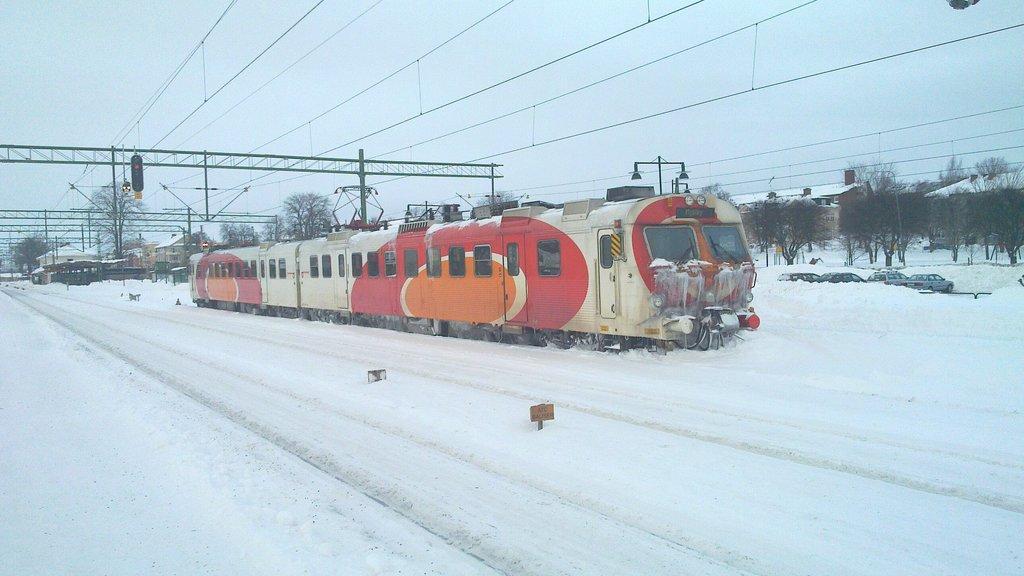Please provide a concise description of this image. In this image we can see a train, snow on the road and objects. In the background we can see trees, houses, electric poles, wires, objects and the sky. 